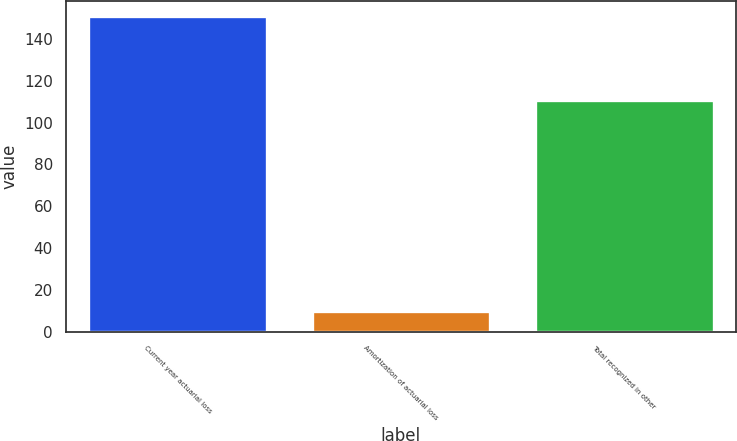<chart> <loc_0><loc_0><loc_500><loc_500><bar_chart><fcel>Current year actuarial loss<fcel>Amortization of actuarial loss<fcel>Total recognized in other<nl><fcel>150.8<fcel>9.9<fcel>110.6<nl></chart> 